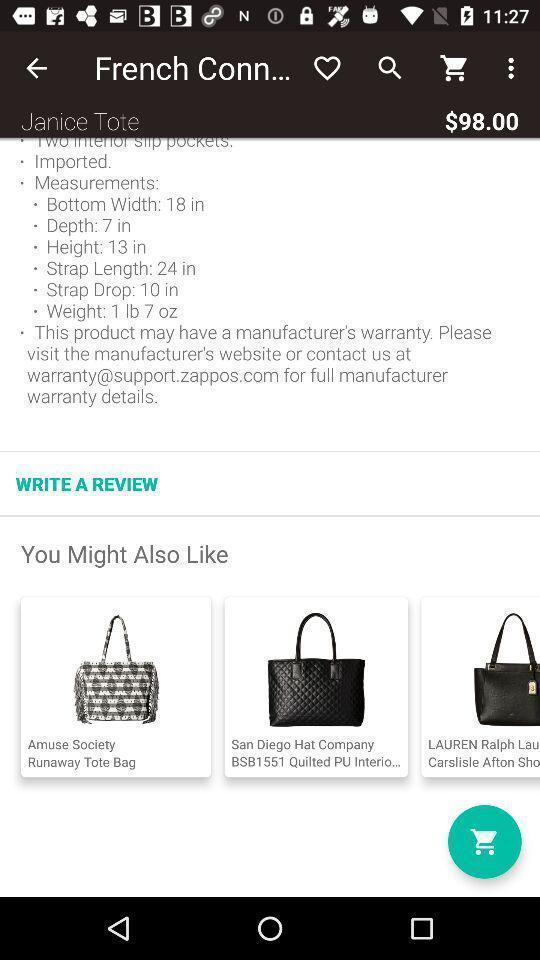Describe the key features of this screenshot. Screen displaying the product details in a shopping app. 